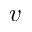Convert formula to latex. <formula><loc_0><loc_0><loc_500><loc_500>v</formula> 